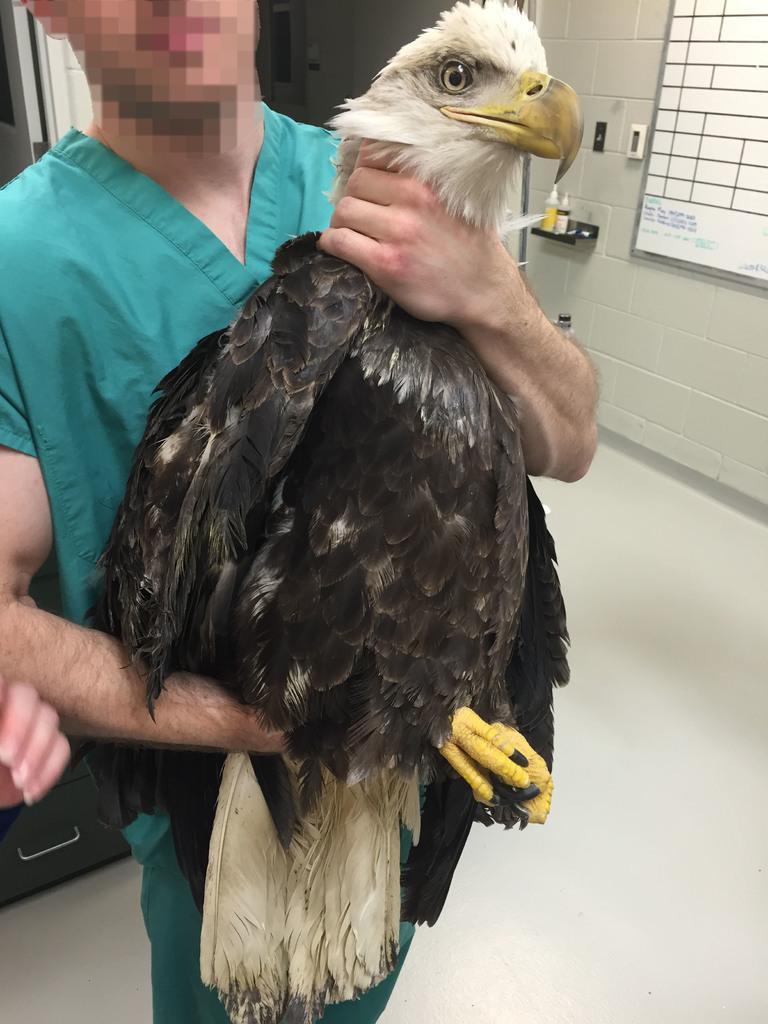In one or two sentences, can you explain what this image depicts? In the image we can see a person wearing clothes and holding a eagle in hand. There is a window, this is a wall and surface, white in color. This is a human hand. 